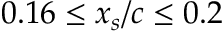Convert formula to latex. <formula><loc_0><loc_0><loc_500><loc_500>0 . 1 6 \leq x _ { s } / c \leq 0 . 2</formula> 